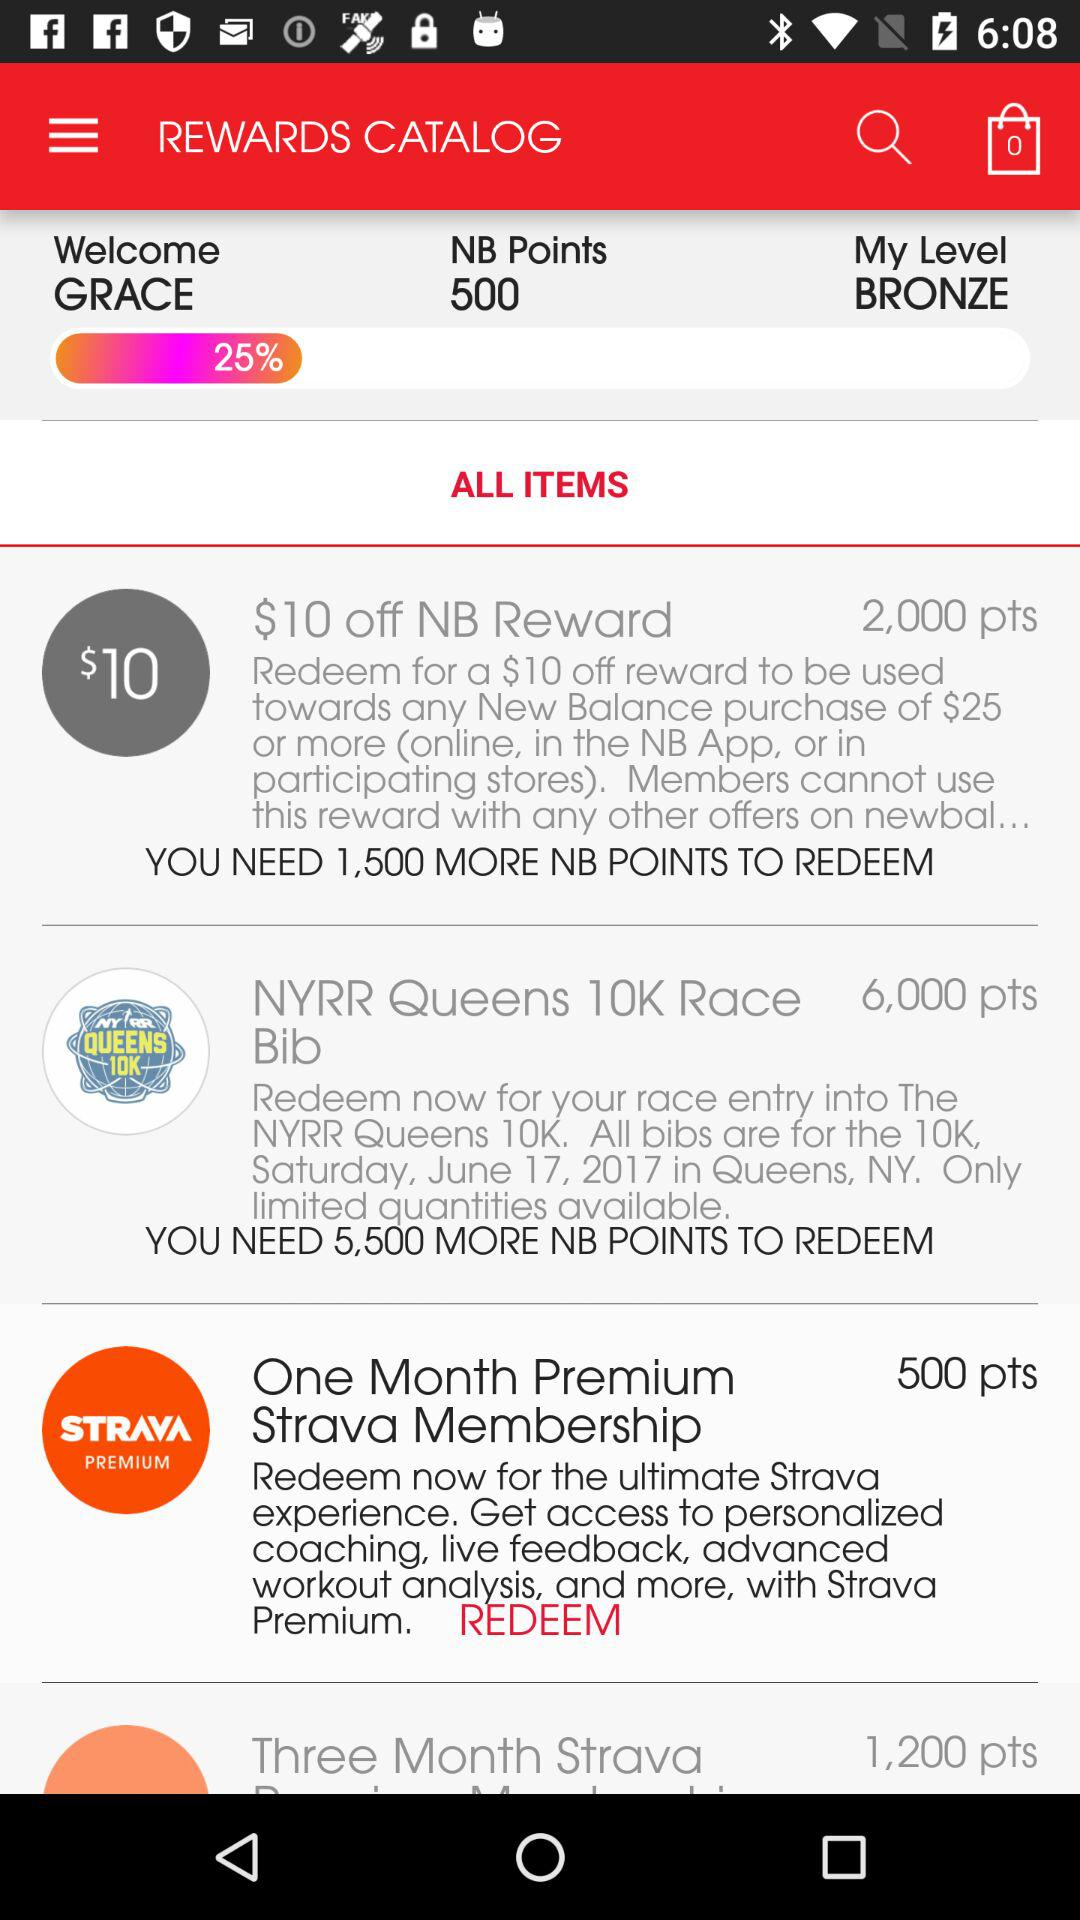How many more points do I need to redeem the NYRR Queens 10K Race Bib?
Answer the question using a single word or phrase. 5,500 